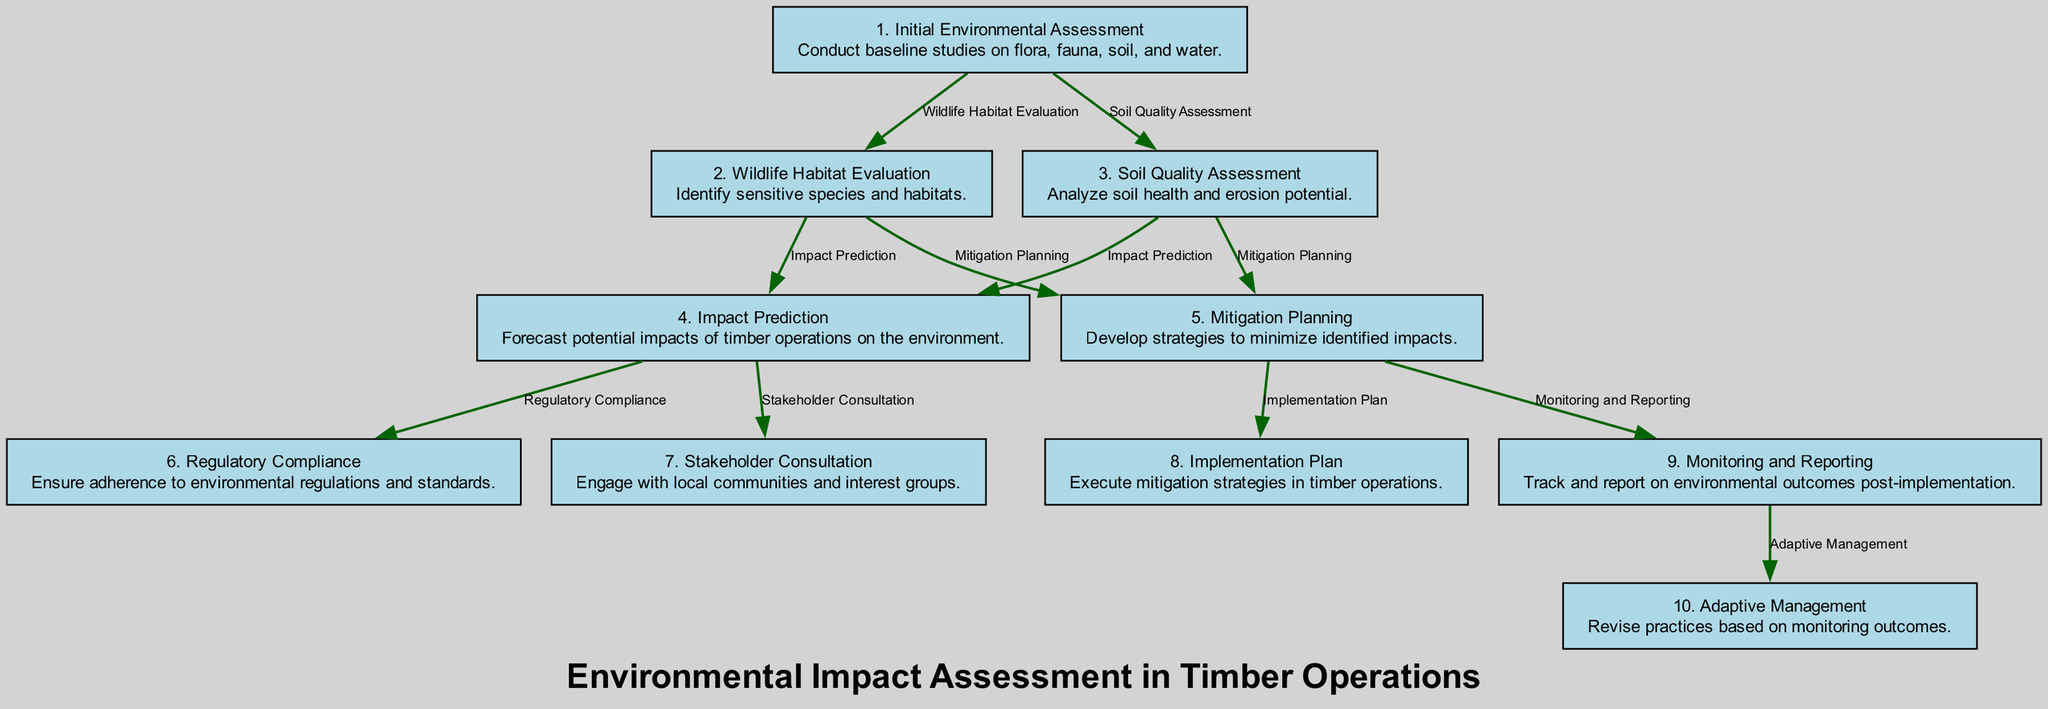What is the first step in the flow chart? The first step in the flow chart is "1. Initial Environmental Assessment," which is the starting point of the assessment and mitigation process in timber operations.
Answer: Initial Environmental Assessment How many total steps are there in the diagram? By counting the numbered nodes in the diagram, we find there are a total of 10 steps represented, from initial assessment to adaptive management.
Answer: 10 What does the "4. Impact Prediction" step lead to? The "4. Impact Prediction" step leads to two subsequent steps: "Regulatory Compliance" and "Stakeholder Consultation" as indicated by the edges stemming from this node.
Answer: Regulatory Compliance, Stakeholder Consultation What is the main goal of the "5. Mitigation Planning" step? The main goal of "5. Mitigation Planning" is to develop strategies that aim to minimize the identified impacts of timber operations on the environment.
Answer: Minimize identified impacts Which step comes after "3. Soil Quality Assessment"? After "3. Soil Quality Assessment," the next steps are "Impact Prediction" and "Mitigation Planning," both of which are the two subsequent stages that follow this assessment of soil quality.
Answer: Impact Prediction, Mitigation Planning What happens in the "10. Adaptive Management" step? In the "10. Adaptive Management" step, practices are revised based on the monitoring outcomes, indicating a response to the data collected and observations made in previous steps.
Answer: Revise practices How many steps involve stakeholder interaction? Two steps involve stakeholder interaction: "7. Stakeholder Consultation," where local communities and interest groups are engaged, and "9. Monitoring and Reporting," which may also involve feedback from stakeholders regarding environmental outcomes.
Answer: 2 Which step focuses specifically on legal adherence? The step that focuses specifically on legal adherence is "6. Regulatory Compliance," which ensures that all regulations and standards are followed throughout the timber operations process.
Answer: Regulatory Compliance 